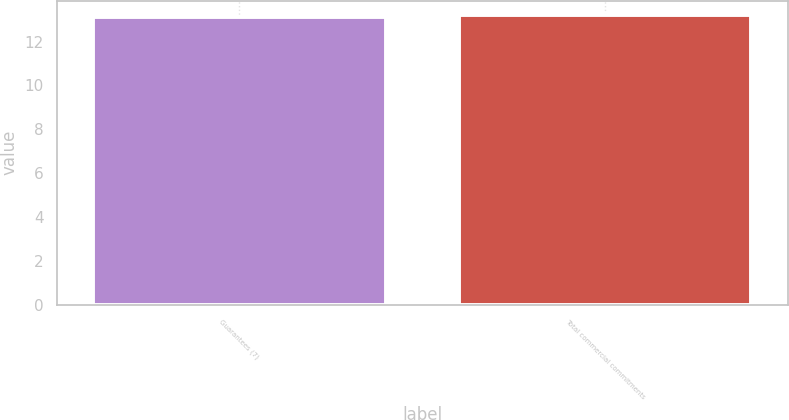Convert chart to OTSL. <chart><loc_0><loc_0><loc_500><loc_500><bar_chart><fcel>Guarantees (7)<fcel>Total commercial commitments<nl><fcel>13.1<fcel>13.2<nl></chart> 